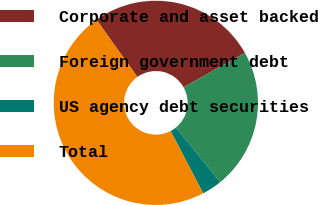Convert chart. <chart><loc_0><loc_0><loc_500><loc_500><pie_chart><fcel>Corporate and asset backed<fcel>Foreign government debt<fcel>US agency debt securities<fcel>Total<nl><fcel>26.75%<fcel>22.28%<fcel>3.18%<fcel>47.79%<nl></chart> 